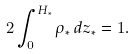Convert formula to latex. <formula><loc_0><loc_0><loc_500><loc_500>2 \int _ { 0 } ^ { H _ { * } } \rho _ { * } \, d z _ { * } = 1 .</formula> 